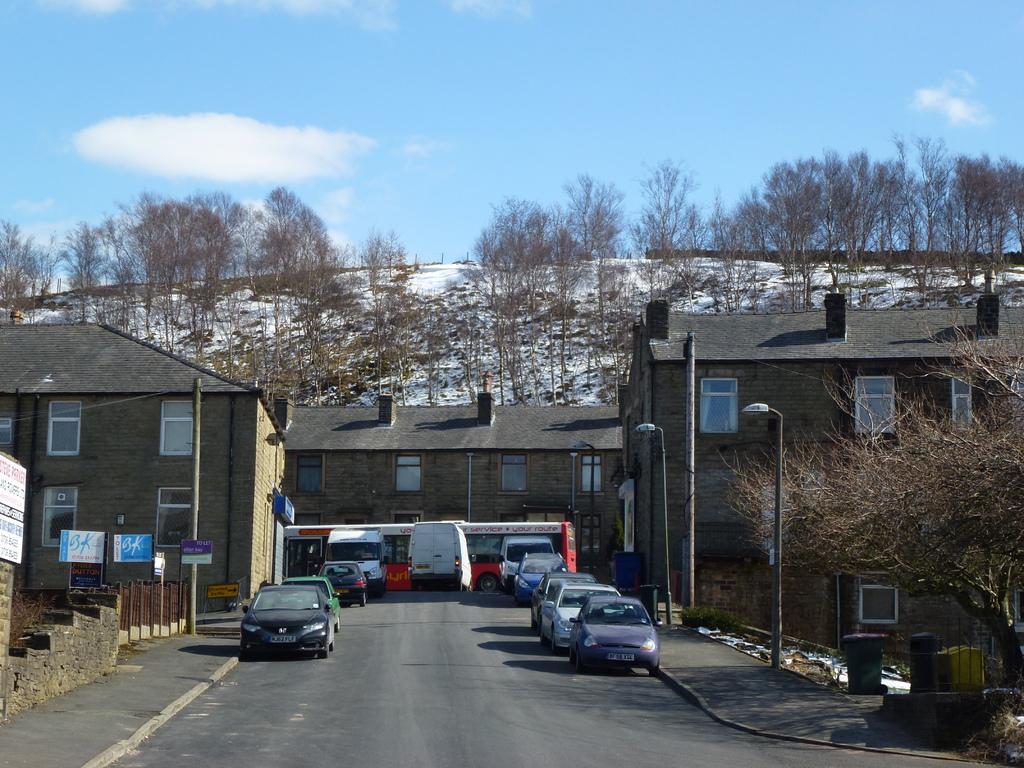Could you give a brief overview of what you see in this image? In this picture we can see vehicles on the road, footpaths, poles, lights, posters, trees, snow, dustbin, buildings with windows and some objects and in the background we can see the sky with clouds. 